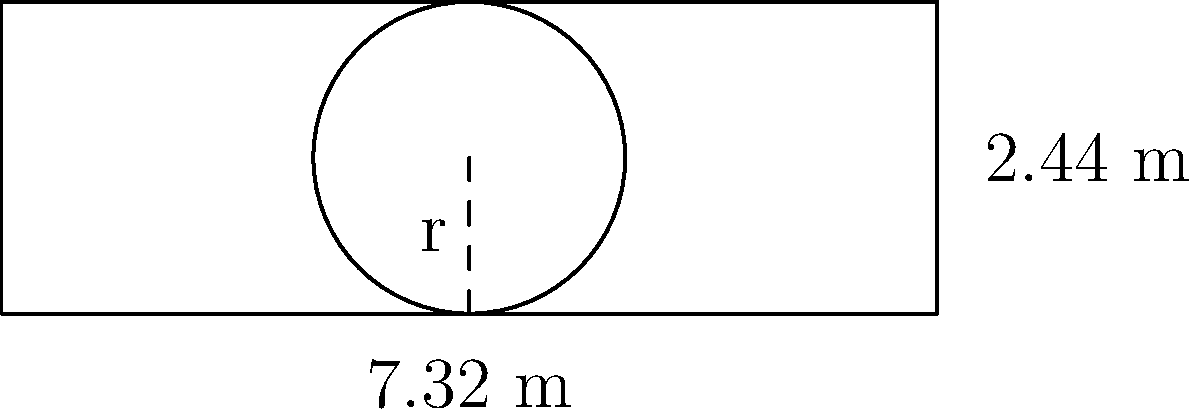A circular advertisement board is to be placed inside a standard football goal post. If the goal post measures 7.32 meters wide and 2.44 meters high, what is the circumference of the largest circular board that can fit inside the goal post? Round your answer to two decimal places. Let's approach this step-by-step:

1) First, we need to find the radius of the largest circle that can fit inside the goal post. This radius will be equal to half the height of the goal post.

   Radius (r) = 2.44 m ÷ 2 = 1.22 m

2) Now that we have the radius, we can use the formula for the circumference of a circle:

   $$C = 2\pi r$$

   Where:
   C = circumference
   π ≈ 3.14159
   r = radius

3) Let's substitute our values:

   $$C = 2 \times 3.14159 \times 1.22$$

4) Calculate:

   $$C = 7.66548 \text{ m}$$

5) Rounding to two decimal places:

   C ≈ 7.67 m

Therefore, the circumference of the largest circular board that can fit inside the goal post is approximately 7.67 meters.
Answer: 7.67 m 